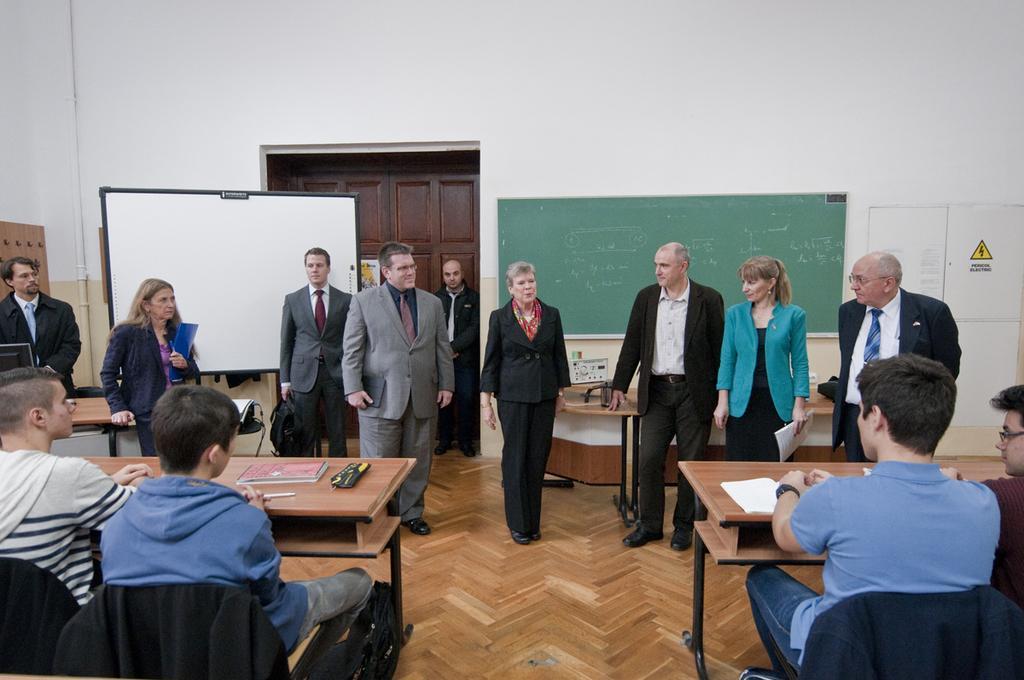Please provide a concise description of this image. As we can see in the image there is a all, door,board, few people sitting over here and tables, chairs and there are four people sitting on chairs. 